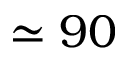<formula> <loc_0><loc_0><loc_500><loc_500>\simeq 9 0</formula> 